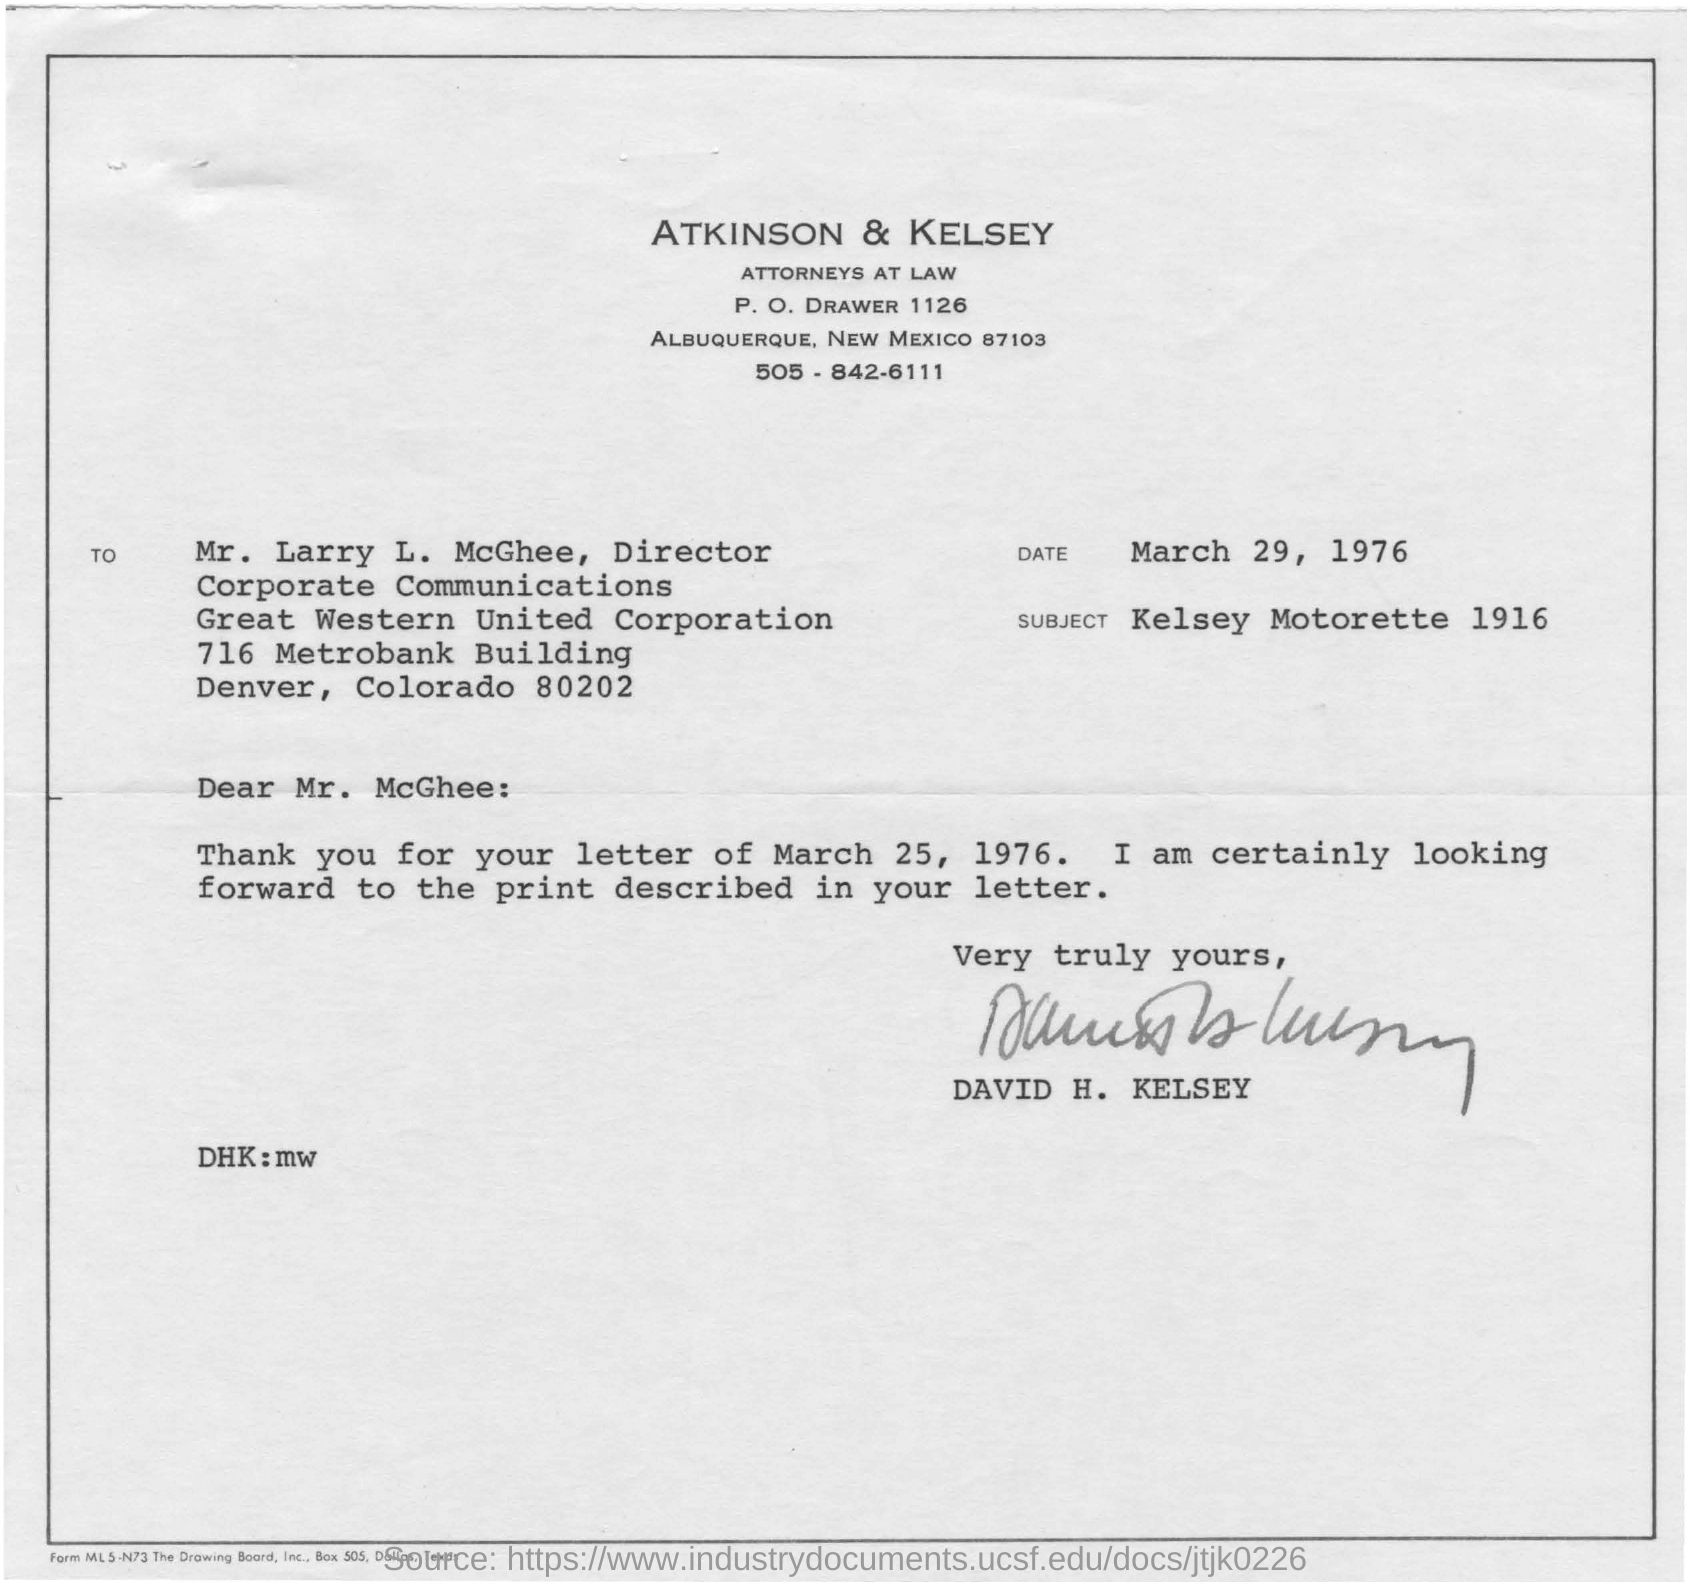By whom was this document written?
Offer a very short reply. DAVID H. KELSEY. What is the date mentioned?
Your response must be concise. March 29, 1976. What is the subject of the document?
Make the answer very short. Kelsey Motorette 1916. 